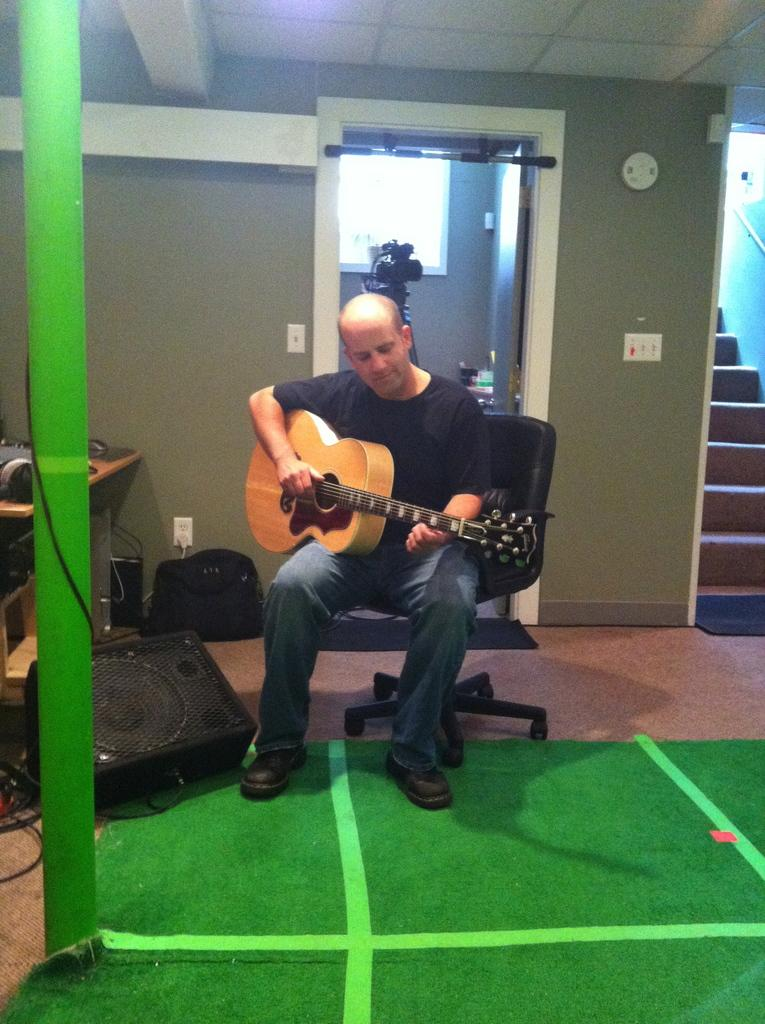What is the main subject of the image? There is a man in the image. What is the man doing in the image? The man is sitting on a chair and holding a guitar in his hand. Can you describe any other objects in the image? There is a pole and a sound box in the image. What type of farming equipment can be seen in the image? There is no farming equipment present in the image. Are there any fairies visible in the image? There are no fairies present in the image. 